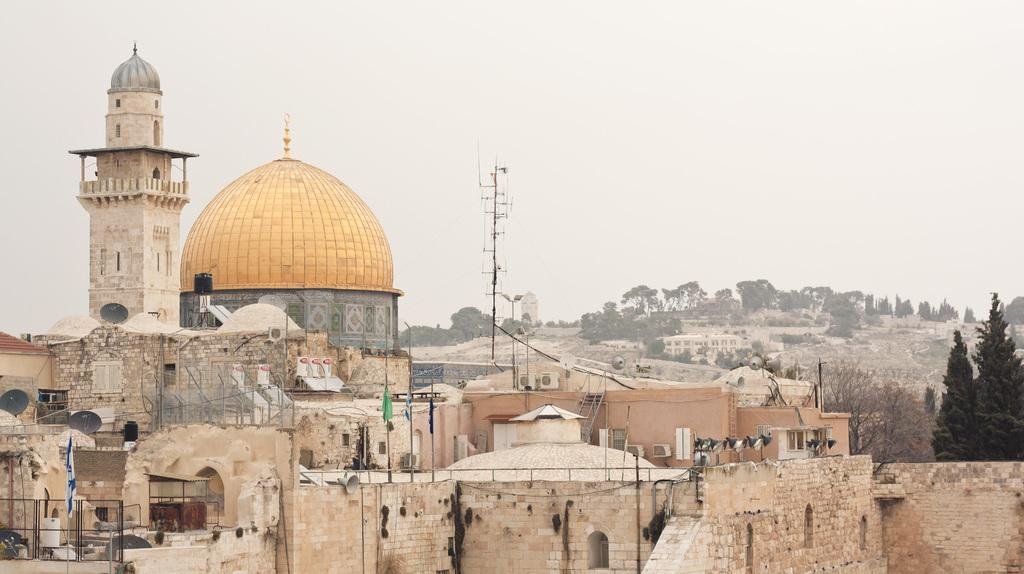What type of material is used for the walls of the buildings in the image? The buildings have brick walls. What communication devices can be seen on the buildings? Dish antennas are visible on the buildings. What can be seen in the background of the image? There are trees and the sky visible in the background of the image. What appliances are present on the buildings? Air conditioners are present on the buildings. What type of doctor is standing next to the building in the image? There is no doctor present in the image; it only features buildings with brick walls, dish antennas, trees, and the sky. 